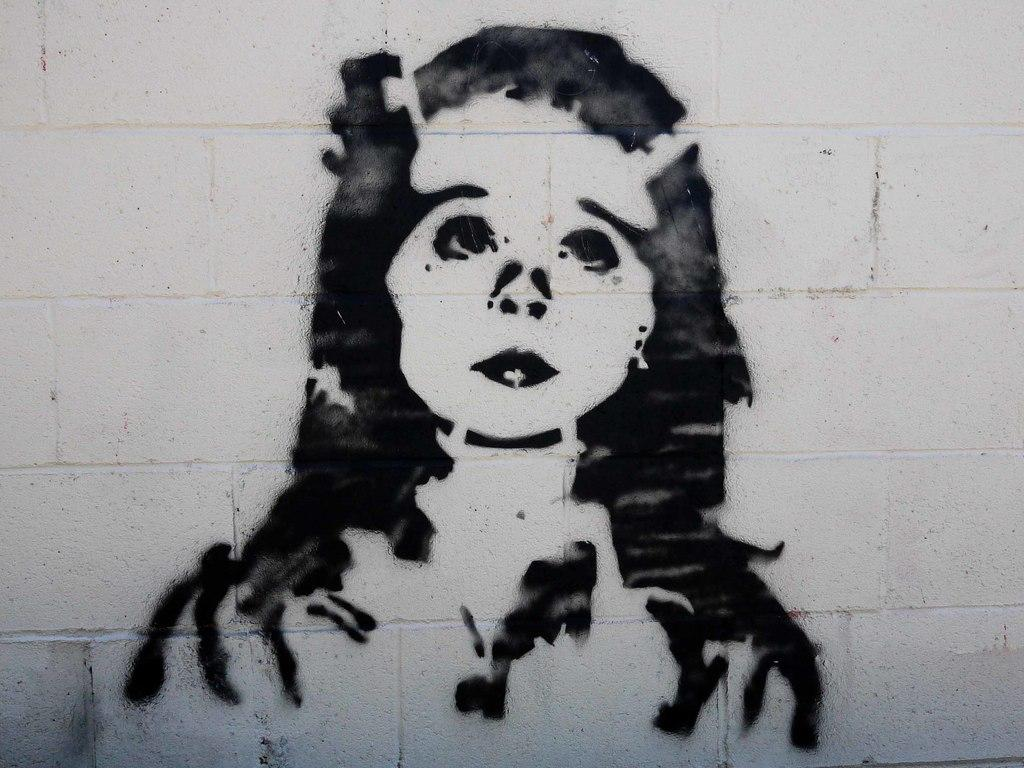What is depicted on the wall in the image? There is an art of a woman on the wall in the image. What type of soup is being served in the image? There is no soup present in the image; it only features an art of a woman on the wall. 